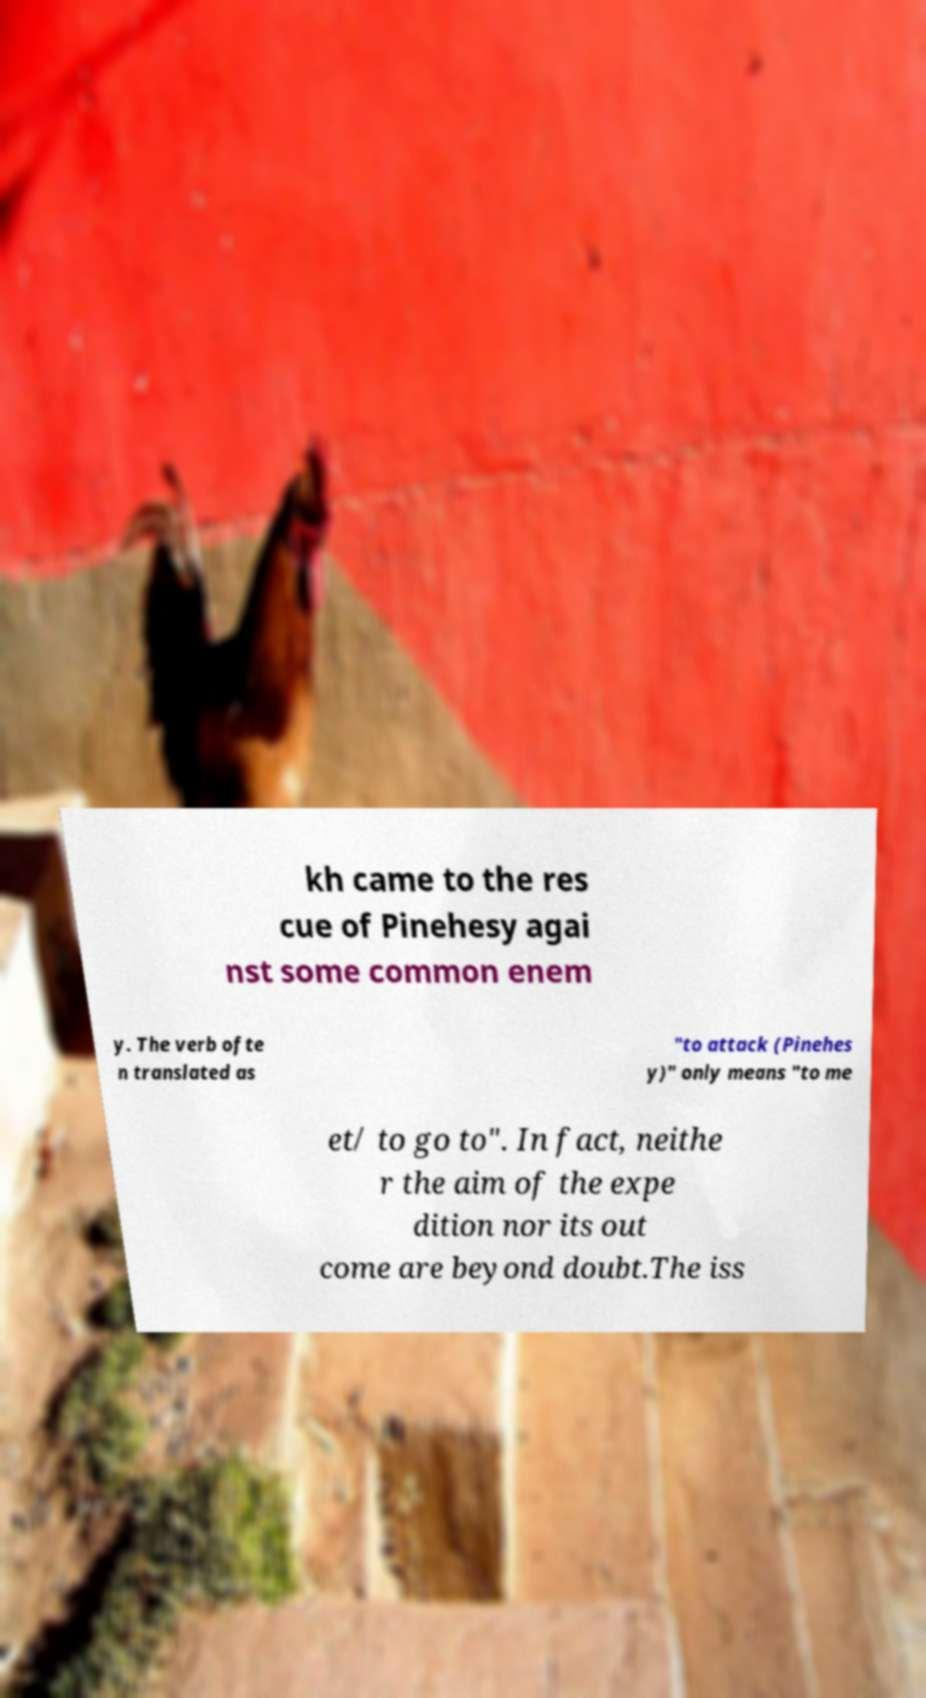Please identify and transcribe the text found in this image. kh came to the res cue of Pinehesy agai nst some common enem y. The verb ofte n translated as "to attack (Pinehes y)" only means "to me et/ to go to". In fact, neithe r the aim of the expe dition nor its out come are beyond doubt.The iss 